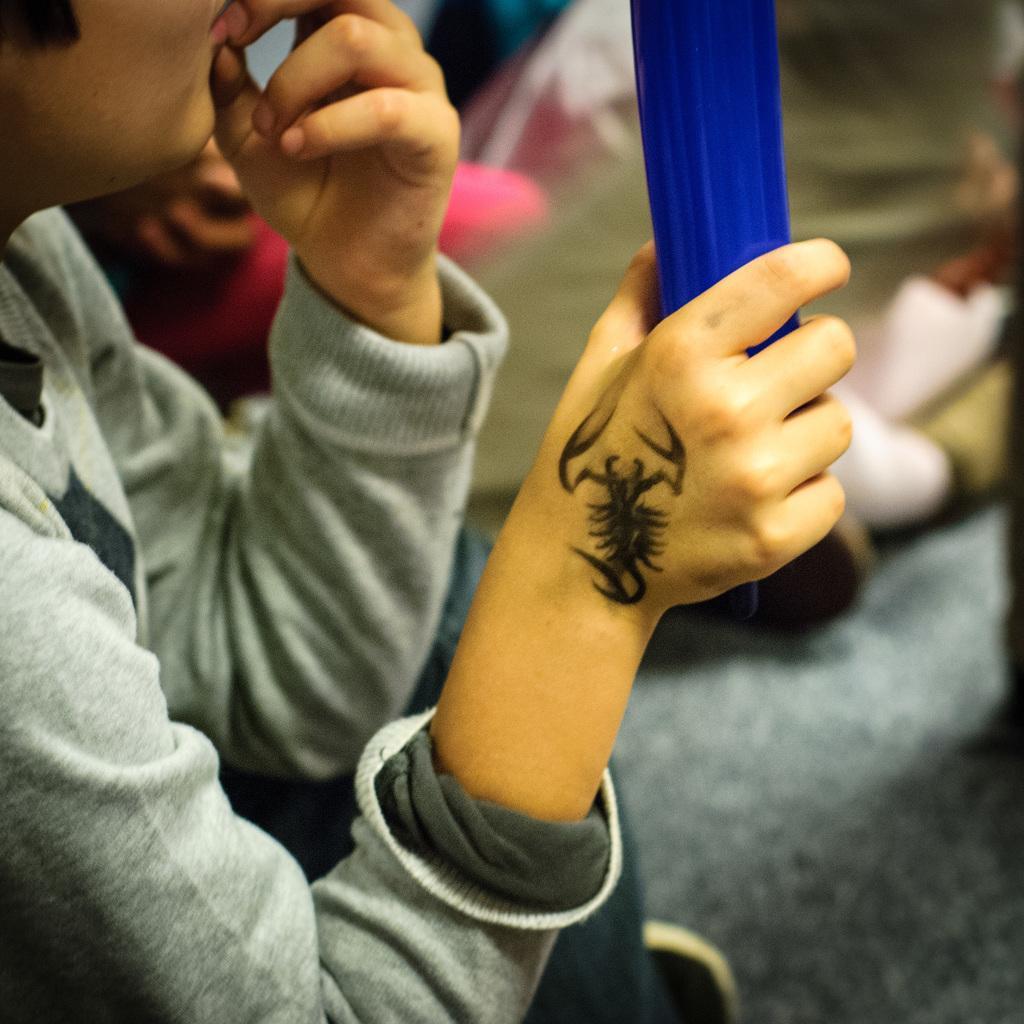Describe this image in one or two sentences. This image consists of a person, who is holding something. He has a tattoo on his hand. He is wearing a grey color T-shirt. 